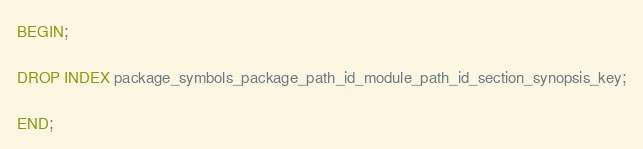<code> <loc_0><loc_0><loc_500><loc_500><_SQL_>BEGIN;

DROP INDEX package_symbols_package_path_id_module_path_id_section_synopsis_key;

END;
</code> 